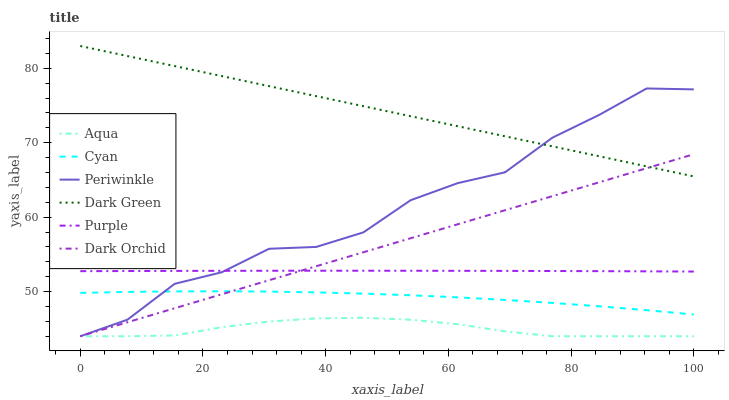Does Aqua have the minimum area under the curve?
Answer yes or no. Yes. Does Dark Green have the maximum area under the curve?
Answer yes or no. Yes. Does Dark Orchid have the minimum area under the curve?
Answer yes or no. No. Does Dark Orchid have the maximum area under the curve?
Answer yes or no. No. Is Dark Orchid the smoothest?
Answer yes or no. Yes. Is Periwinkle the roughest?
Answer yes or no. Yes. Is Aqua the smoothest?
Answer yes or no. No. Is Aqua the roughest?
Answer yes or no. No. Does Aqua have the lowest value?
Answer yes or no. Yes. Does Cyan have the lowest value?
Answer yes or no. No. Does Dark Green have the highest value?
Answer yes or no. Yes. Does Dark Orchid have the highest value?
Answer yes or no. No. Is Aqua less than Dark Green?
Answer yes or no. Yes. Is Cyan greater than Aqua?
Answer yes or no. Yes. Does Periwinkle intersect Dark Orchid?
Answer yes or no. Yes. Is Periwinkle less than Dark Orchid?
Answer yes or no. No. Is Periwinkle greater than Dark Orchid?
Answer yes or no. No. Does Aqua intersect Dark Green?
Answer yes or no. No. 